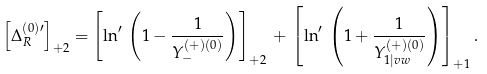<formula> <loc_0><loc_0><loc_500><loc_500>\left [ \Delta _ { R } ^ { ( 0 ) \prime } \right ] _ { + 2 } = \left [ \ln ^ { \prime } \, \left ( 1 - \frac { 1 } { Y _ { - } ^ { ( + ) ( 0 ) } } \right ) \right ] _ { + 2 } \, + \, \left [ \ln ^ { \prime } \, \left ( 1 + \frac { 1 } { Y _ { 1 | v w } ^ { ( + ) ( 0 ) } } \right ) \right ] _ { + 1 } .</formula> 